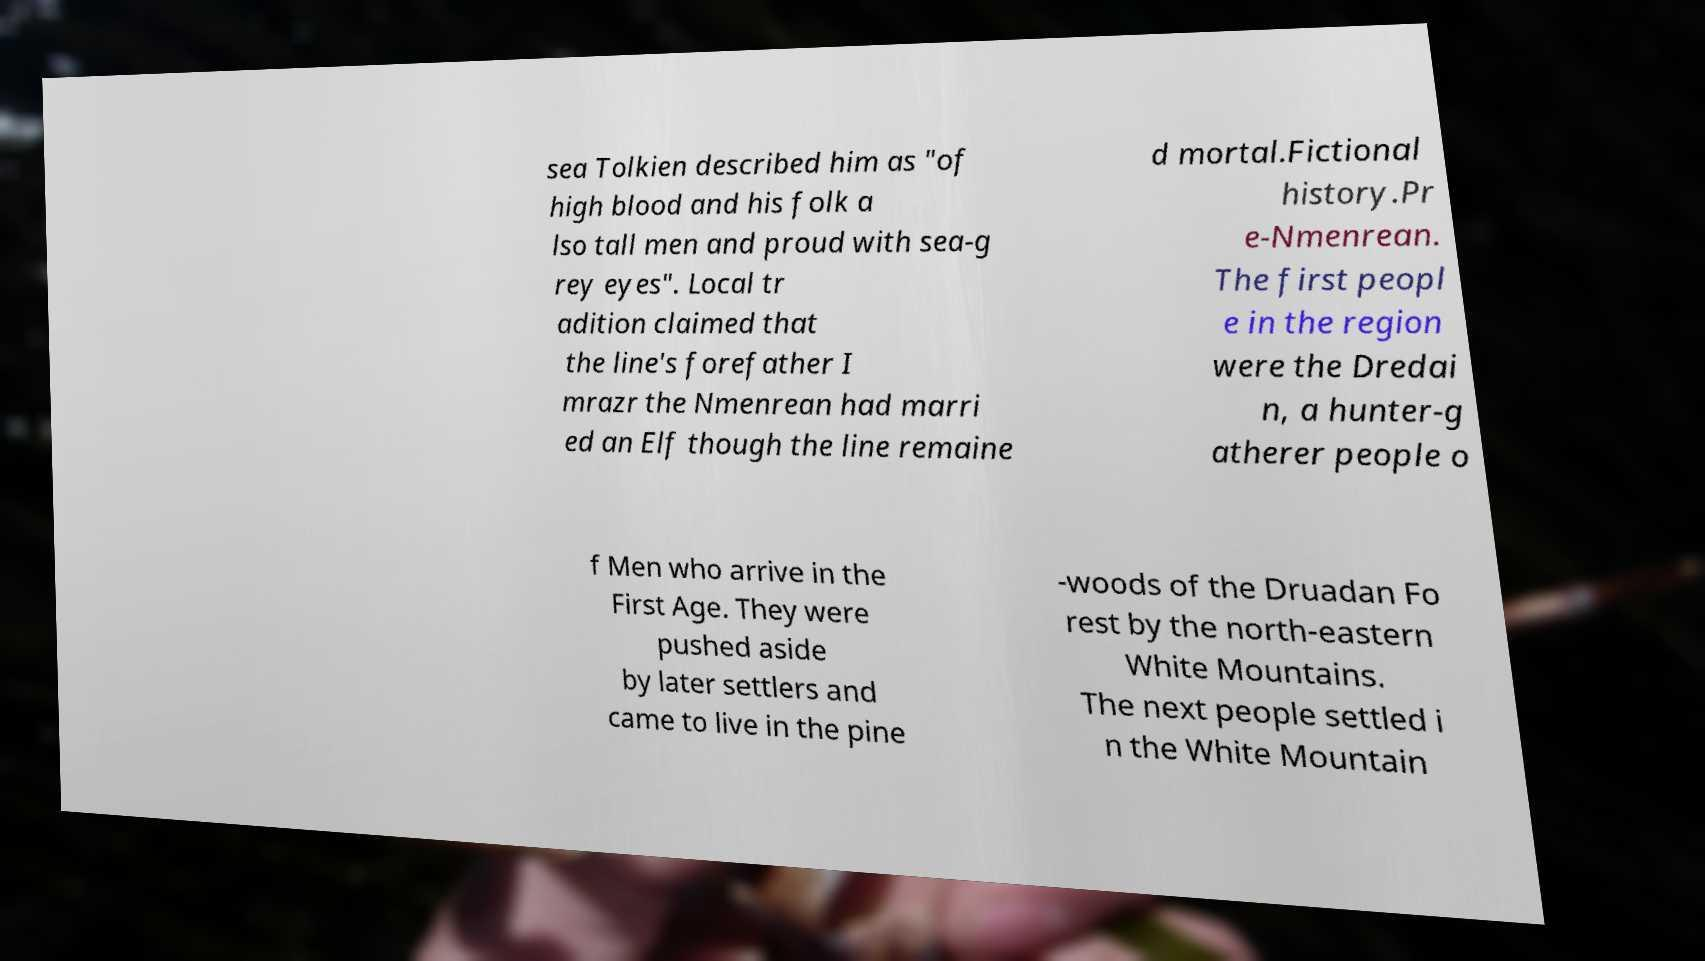Can you read and provide the text displayed in the image?This photo seems to have some interesting text. Can you extract and type it out for me? sea Tolkien described him as "of high blood and his folk a lso tall men and proud with sea-g rey eyes". Local tr adition claimed that the line's forefather I mrazr the Nmenrean had marri ed an Elf though the line remaine d mortal.Fictional history.Pr e-Nmenrean. The first peopl e in the region were the Dredai n, a hunter-g atherer people o f Men who arrive in the First Age. They were pushed aside by later settlers and came to live in the pine -woods of the Druadan Fo rest by the north-eastern White Mountains. The next people settled i n the White Mountain 